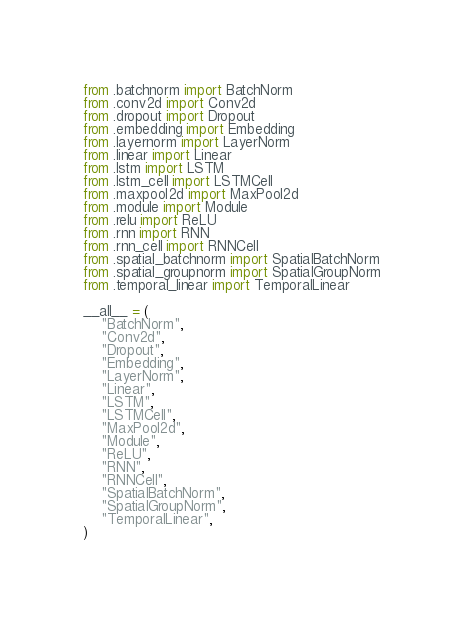<code> <loc_0><loc_0><loc_500><loc_500><_Python_>from .batchnorm import BatchNorm
from .conv2d import Conv2d
from .dropout import Dropout
from .embedding import Embedding
from .layernorm import LayerNorm
from .linear import Linear
from .lstm import LSTM
from .lstm_cell import LSTMCell
from .maxpool2d import MaxPool2d
from .module import Module
from .relu import ReLU
from .rnn import RNN
from .rnn_cell import RNNCell
from .spatial_batchnorm import SpatialBatchNorm
from .spatial_groupnorm import SpatialGroupNorm
from .temporal_linear import TemporalLinear

__all__ = (
    "BatchNorm",
    "Conv2d",
    "Dropout",
    "Embedding",
    "LayerNorm",
    "Linear",
    "LSTM",
    "LSTMCell",
    "MaxPool2d",
    "Module",
    "ReLU",
    "RNN",
    "RNNCell",
    "SpatialBatchNorm",
    "SpatialGroupNorm",
    "TemporalLinear",
)
</code> 